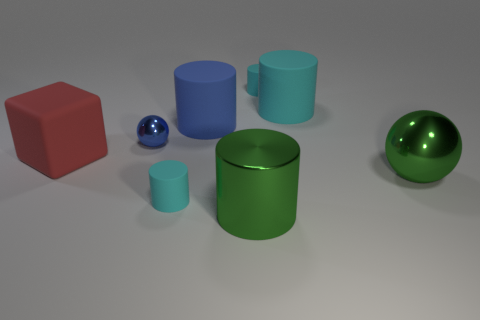Subtract all purple blocks. How many cyan cylinders are left? 3 Subtract all big green shiny cylinders. How many cylinders are left? 4 Subtract 2 cylinders. How many cylinders are left? 3 Subtract all green cylinders. How many cylinders are left? 4 Subtract all blue cylinders. Subtract all green balls. How many cylinders are left? 4 Add 1 small cyan blocks. How many objects exist? 9 Subtract all blocks. How many objects are left? 7 Subtract 0 purple cubes. How many objects are left? 8 Subtract all green metal cylinders. Subtract all large blocks. How many objects are left? 6 Add 6 large blue rubber cylinders. How many large blue rubber cylinders are left? 7 